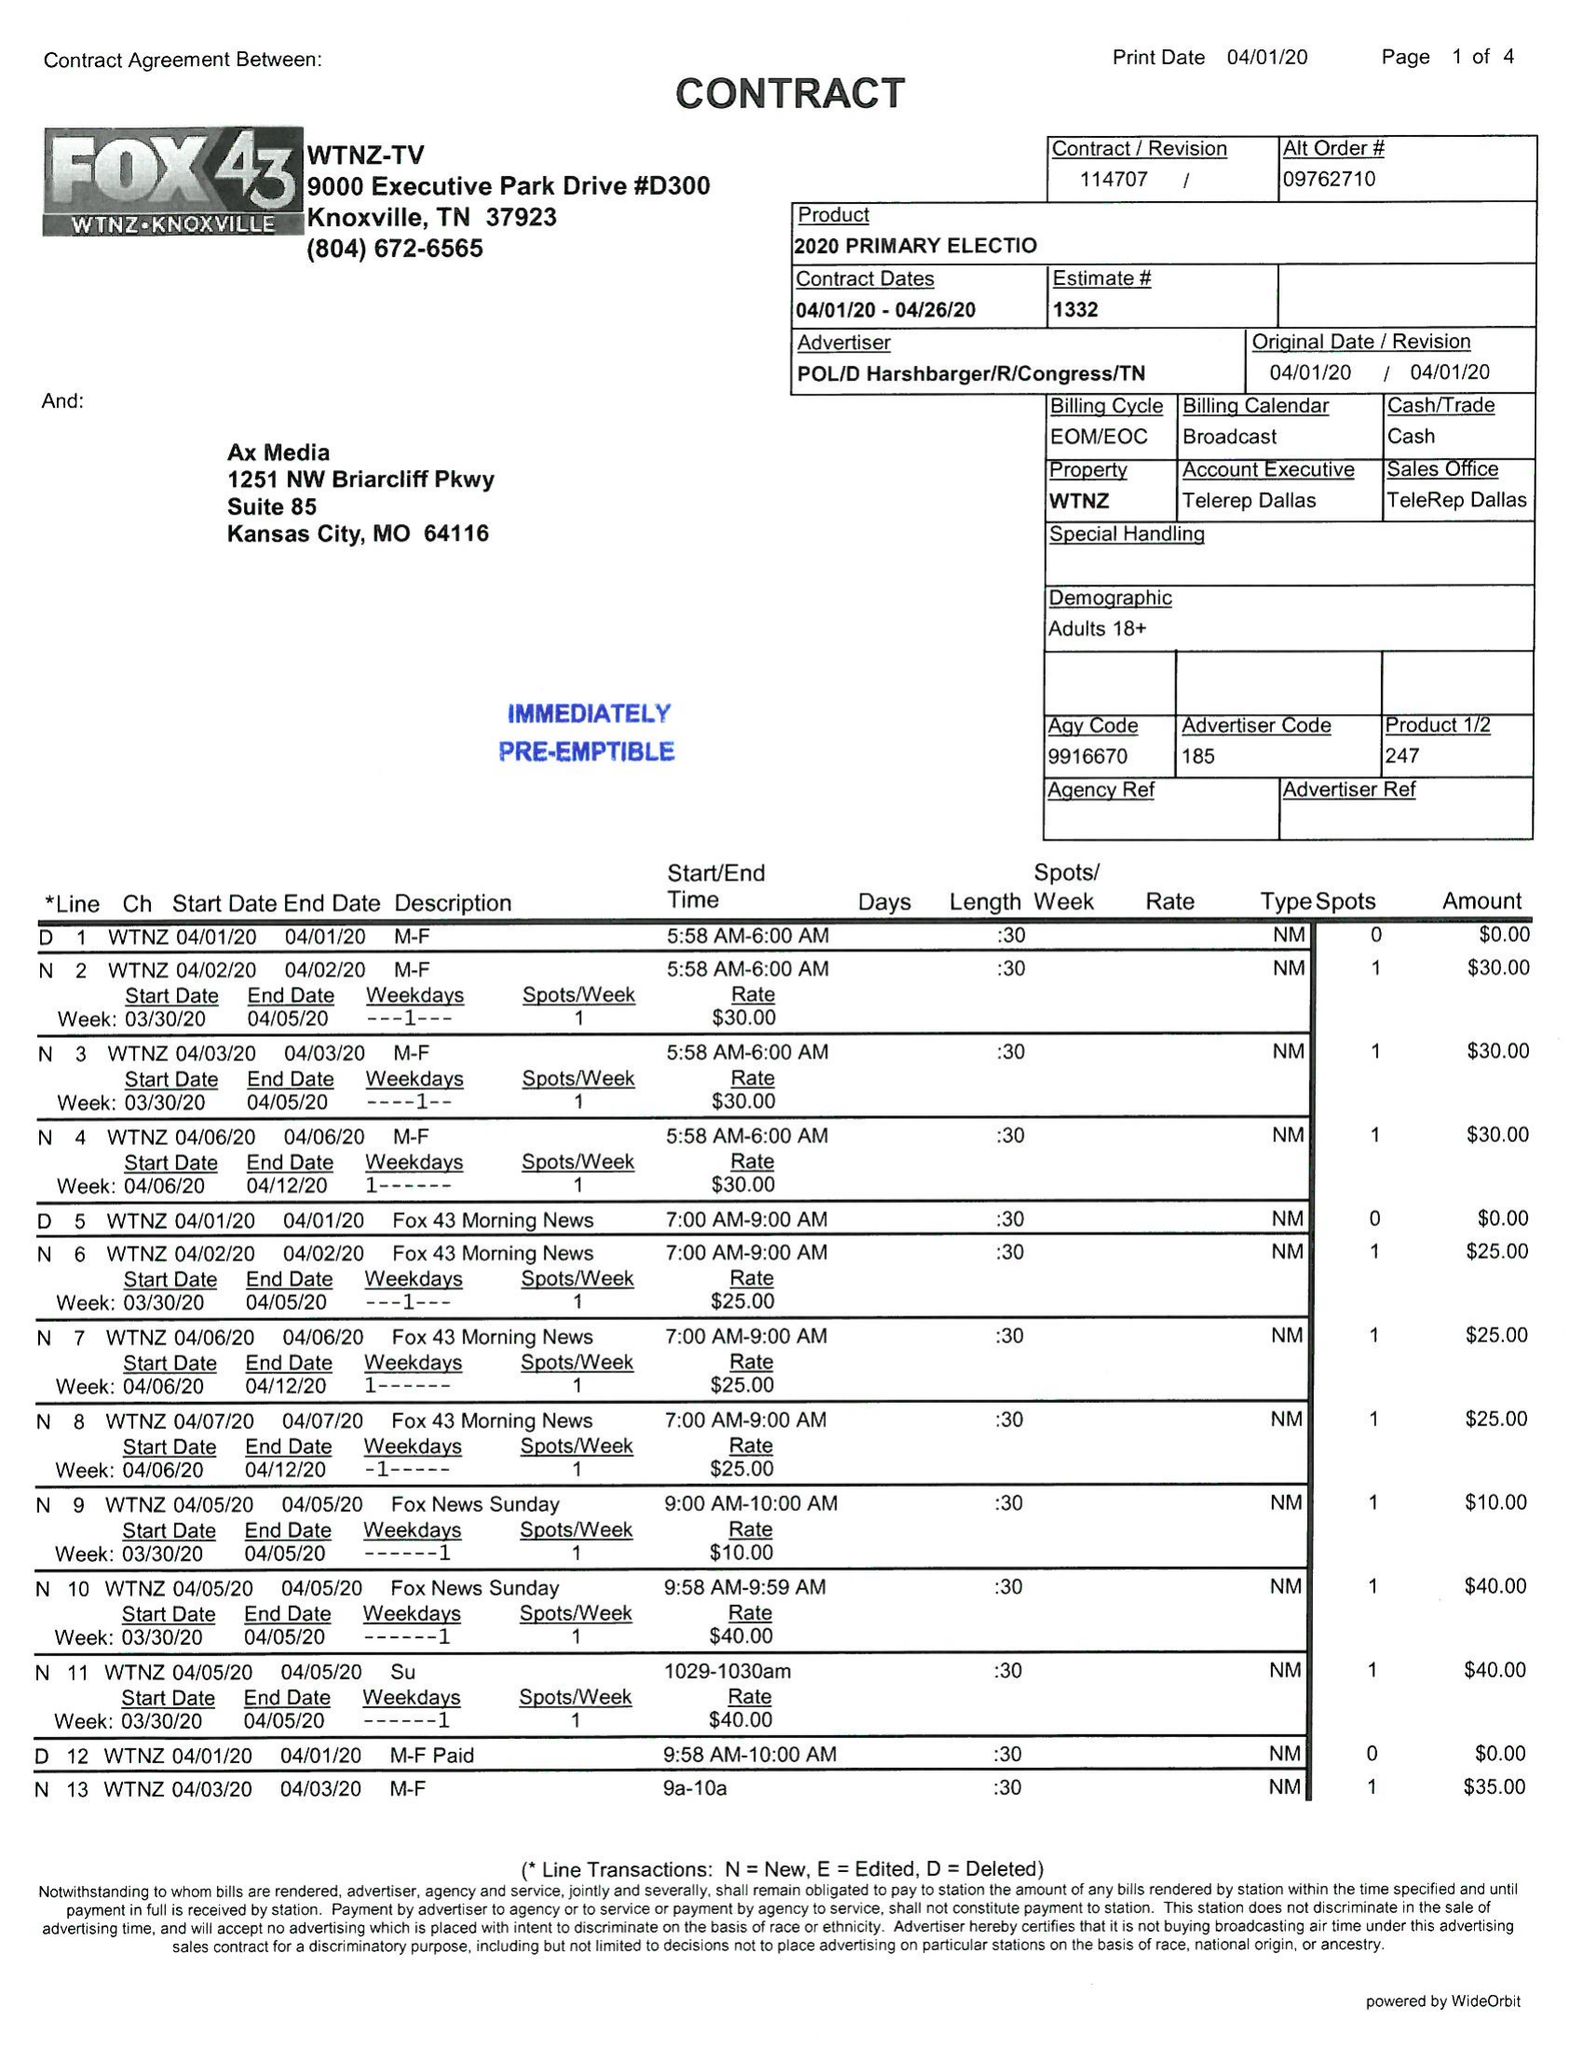What is the value for the flight_from?
Answer the question using a single word or phrase. 04/01/20 